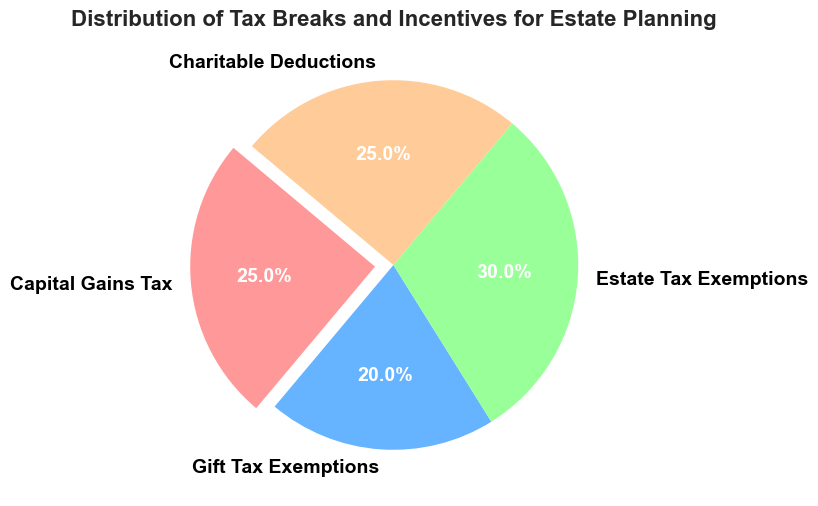What percentage of tax breaks are attributed to Capital Gains Tax and Gift Tax Exemptions combined? To find the percentage of tax breaks attributed to Capital Gains Tax and Gift Tax Exemptions, add their respective percentages: 25% (Capital Gains Tax) + 20% (Gift Tax Exemptions) = 45%
Answer: 45% Which category has the highest percentage of tax breaks? By examining the pie chart, the category with the largest slice is Estate Tax Exemptions, which holds 30% of the tax breaks.
Answer: Estate Tax Exemptions How much larger is the Estate Tax Exemptions percentage compared to the Gift Tax Exemptions percentage? Subtract the Gift Tax Exemptions percentage from the Estate Tax Exemptions percentage: 30% (Estate Tax Exemptions) - 20% (Gift Tax Exemptions) = 10%
Answer: 10% What is the sum of the percentages for Charitable Deductions and Capital Gains Tax? Add the percentages for Charitable Deductions and Capital Gains Tax: 25% (Charitable Deductions) + 25% (Capital Gains Tax) = 50%
Answer: 50% Which category is represented by the slice that is slightly separated from the pie? The slice that is slightly separated from the pie is the one with an explode parameter, which in this case is Capital Gains Tax.
Answer: Capital Gains Tax 